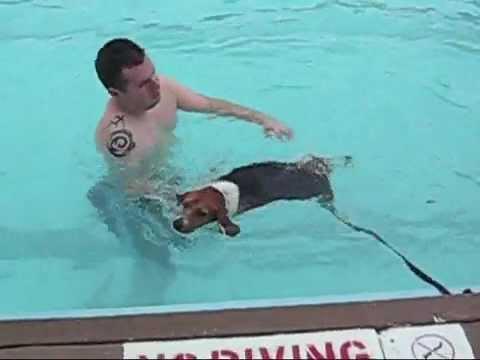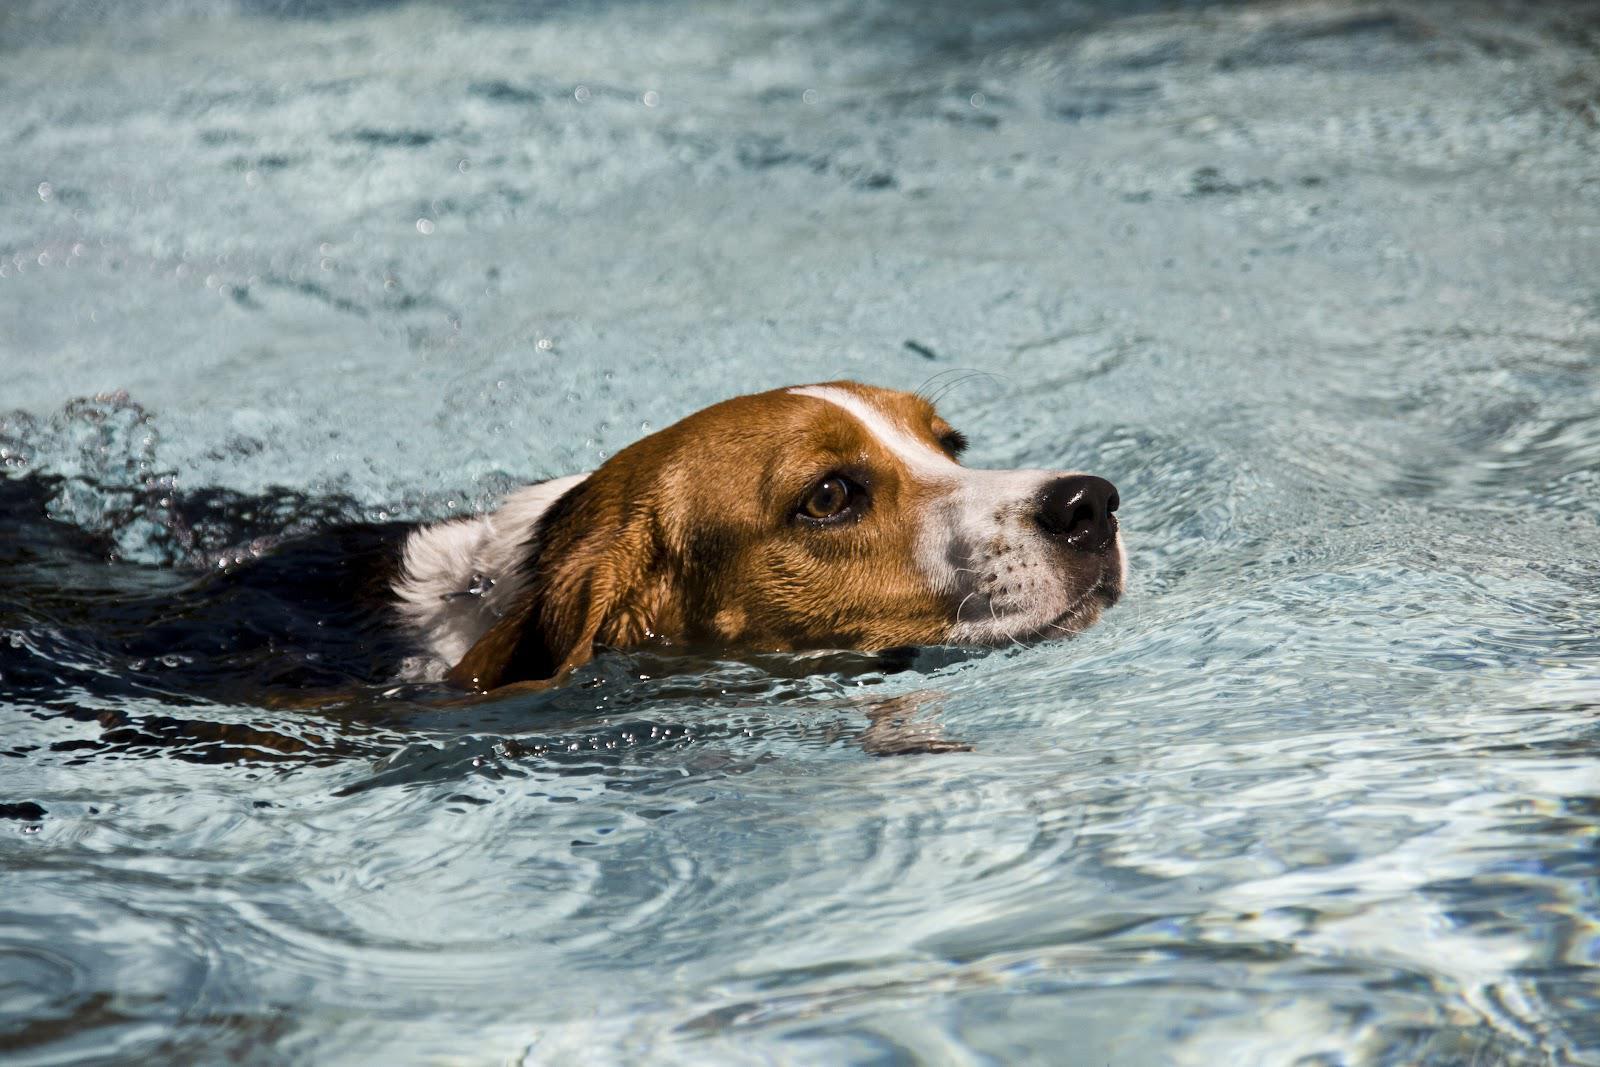The first image is the image on the left, the second image is the image on the right. Considering the images on both sides, is "A person is visible in a pool that also has a dog in it." valid? Answer yes or no. Yes. The first image is the image on the left, the second image is the image on the right. For the images displayed, is the sentence "There are two dogs in total." factually correct? Answer yes or no. Yes. 